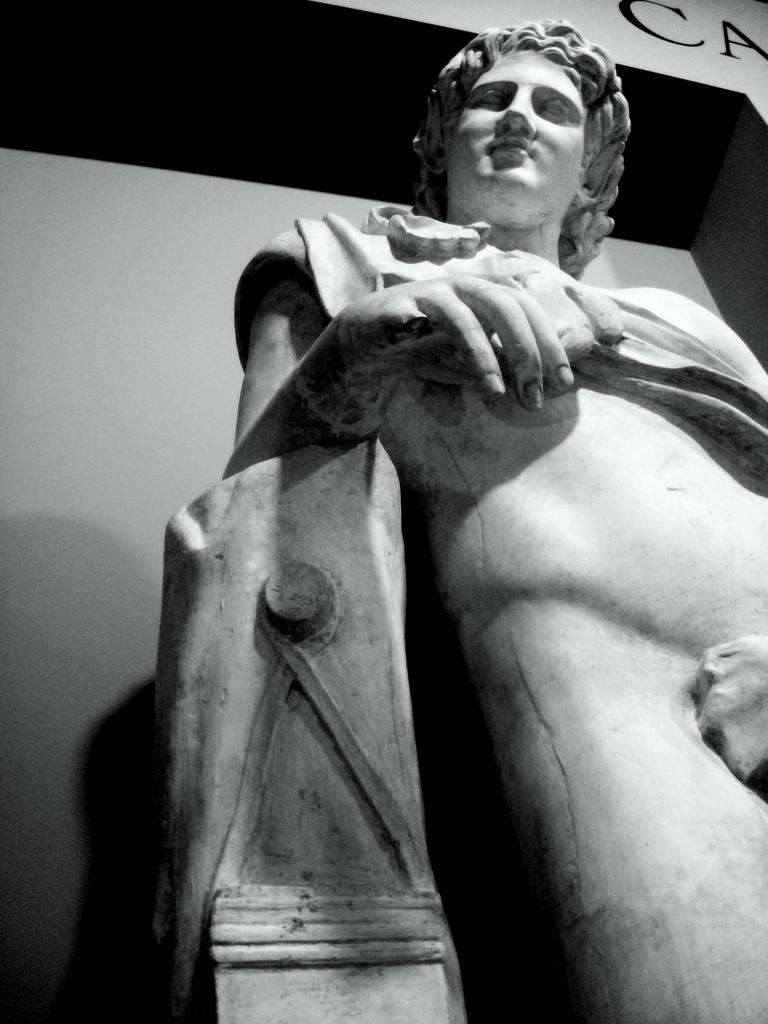What is the main subject in the image? There is a statue in the image. What can be seen in the background of the image? There is a wall with white and black colors in the image. Is there any text visible on the wall? Yes, the wall has some text written on it, which appears to be "CA". What type of degree is being awarded to the statue in the image? There is no indication of a degree being awarded in the image; it features a statue and a wall with text. What type of prose can be seen on the wall in the image? There is no prose visible on the wall in the image; it only has the text "CA". 